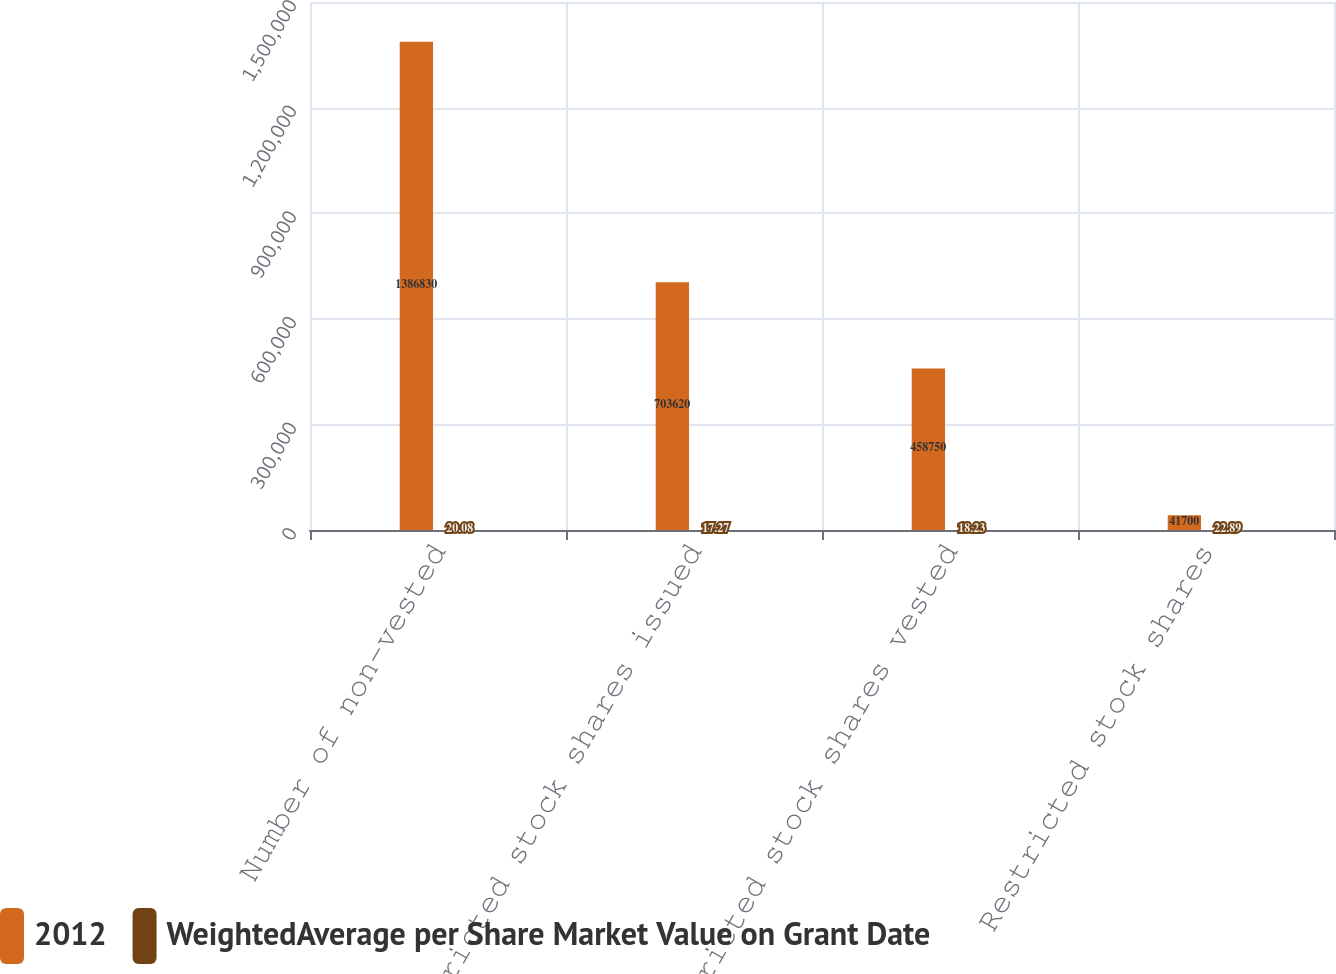Convert chart. <chart><loc_0><loc_0><loc_500><loc_500><stacked_bar_chart><ecel><fcel>Number of non-vested<fcel>Restricted stock shares issued<fcel>Restricted stock shares vested<fcel>Restricted stock shares<nl><fcel>2012<fcel>1.38683e+06<fcel>703620<fcel>458750<fcel>41700<nl><fcel>WeightedAverage per Share Market Value on Grant Date<fcel>20.08<fcel>17.27<fcel>18.23<fcel>22.89<nl></chart> 